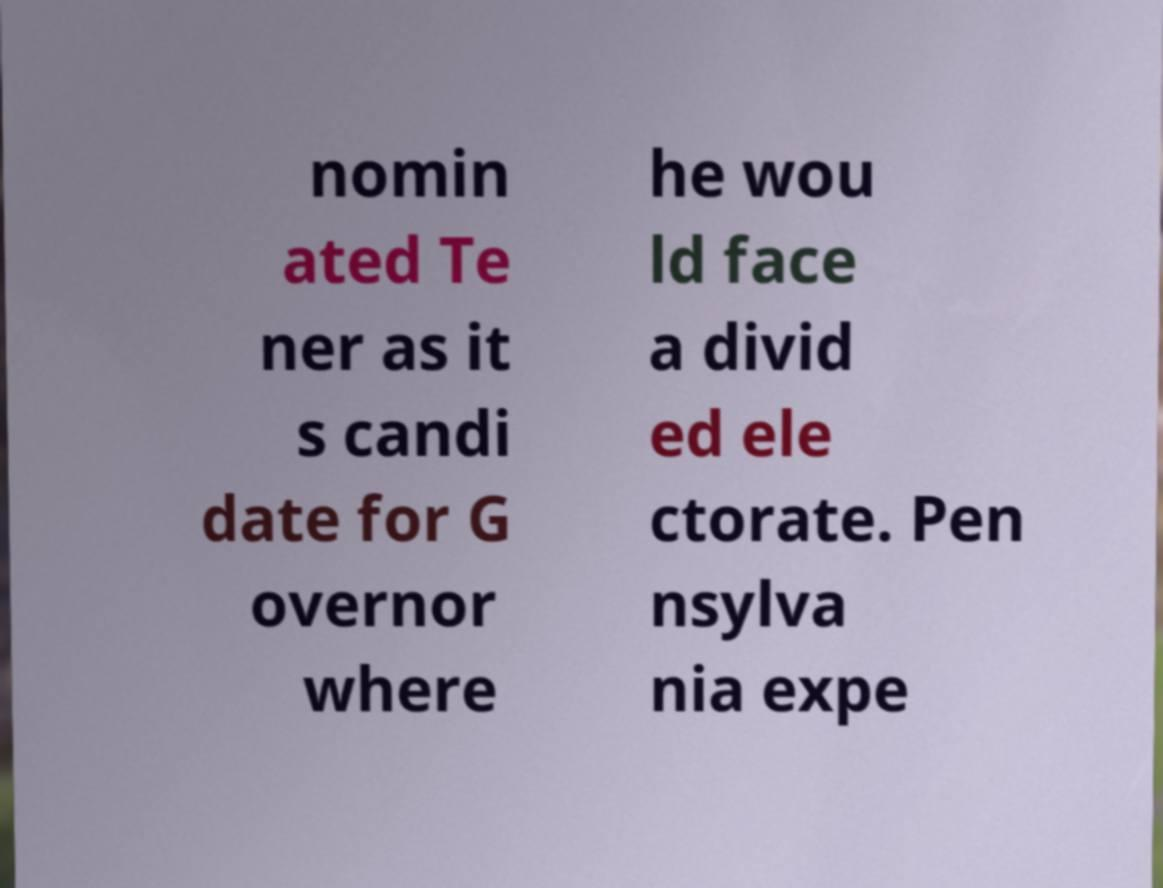Please read and relay the text visible in this image. What does it say? nomin ated Te ner as it s candi date for G overnor where he wou ld face a divid ed ele ctorate. Pen nsylva nia expe 